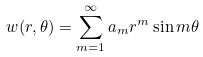Convert formula to latex. <formula><loc_0><loc_0><loc_500><loc_500>w ( r , \theta ) = \sum _ { m = 1 } ^ { \infty } a _ { m } r ^ { m } \sin m \theta</formula> 